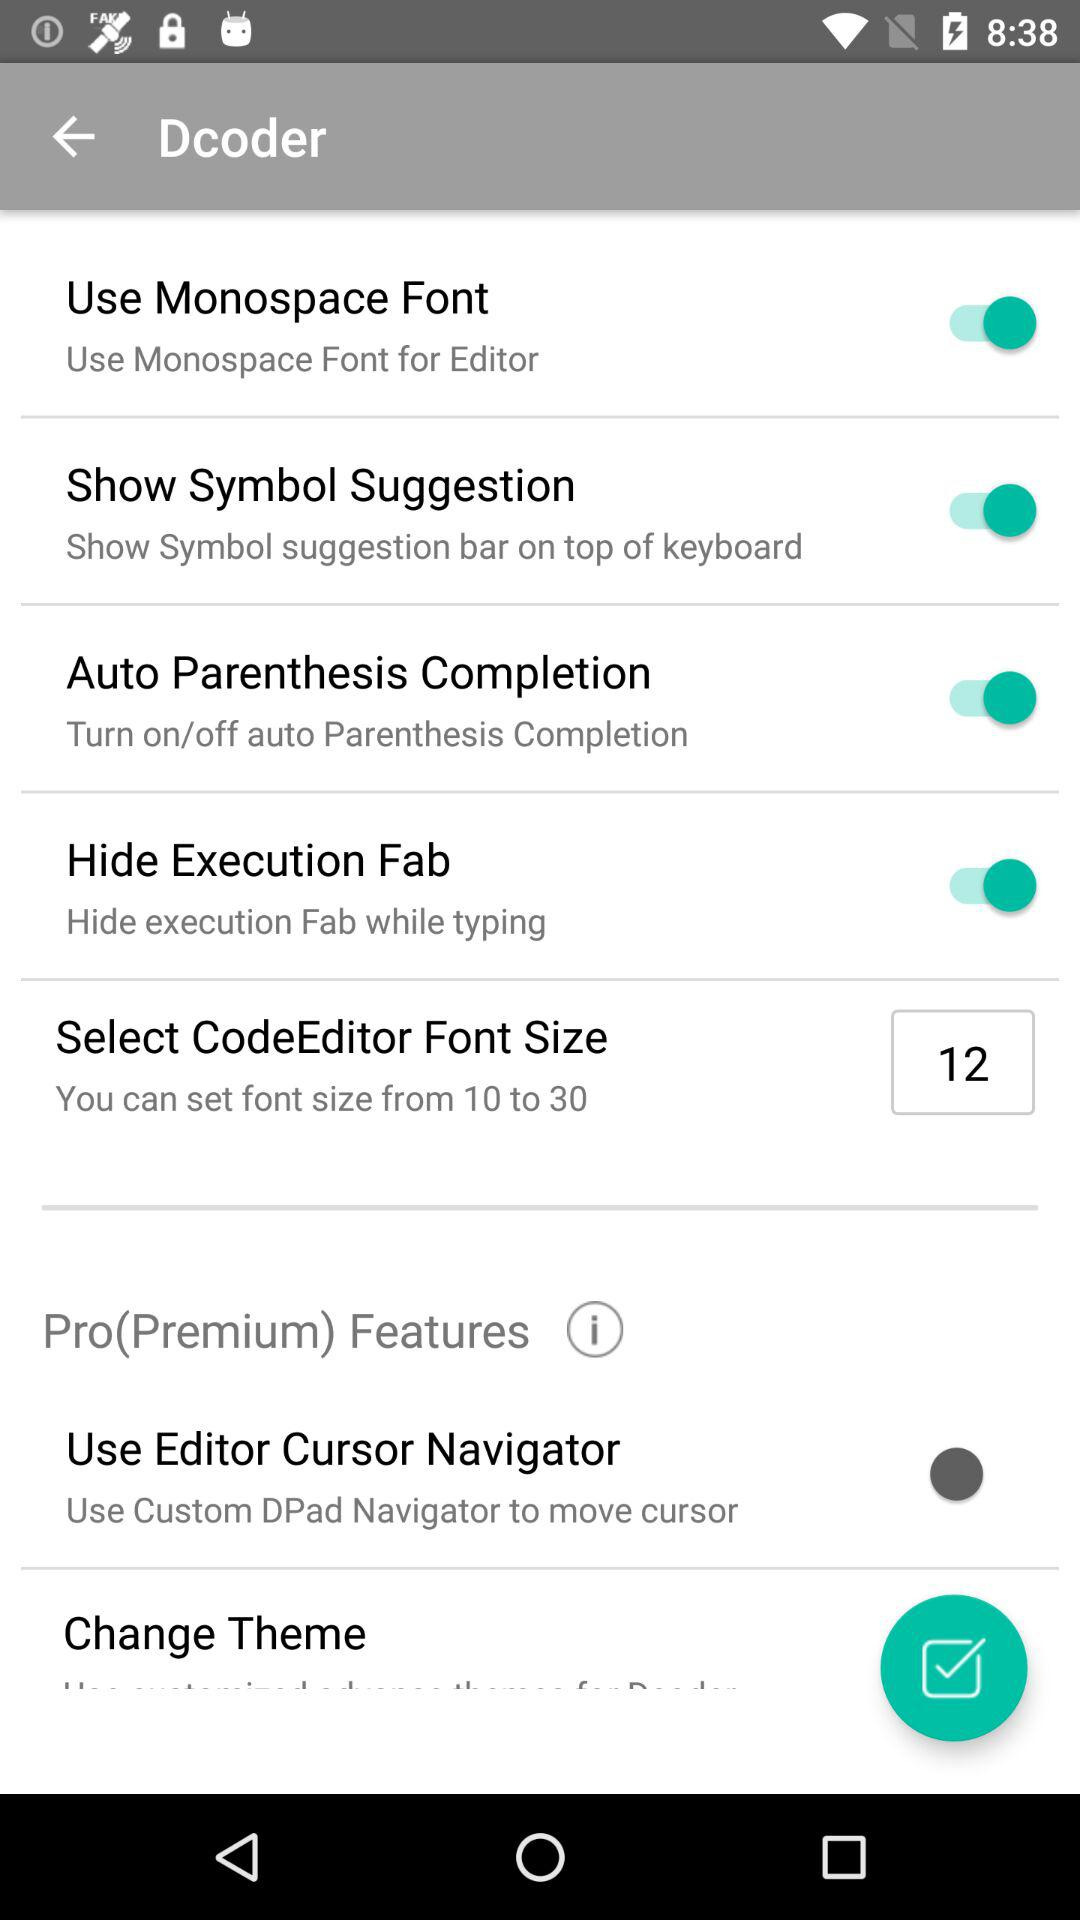What is the range of font size? The range of font size is from 10 to 30. 